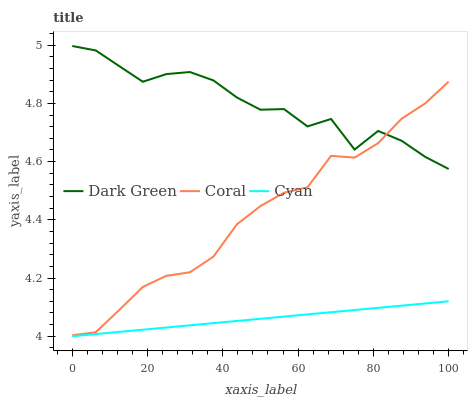Does Cyan have the minimum area under the curve?
Answer yes or no. Yes. Does Dark Green have the maximum area under the curve?
Answer yes or no. Yes. Does Coral have the minimum area under the curve?
Answer yes or no. No. Does Coral have the maximum area under the curve?
Answer yes or no. No. Is Cyan the smoothest?
Answer yes or no. Yes. Is Dark Green the roughest?
Answer yes or no. Yes. Is Coral the smoothest?
Answer yes or no. No. Is Coral the roughest?
Answer yes or no. No. Does Cyan have the lowest value?
Answer yes or no. Yes. Does Coral have the lowest value?
Answer yes or no. No. Does Dark Green have the highest value?
Answer yes or no. Yes. Does Coral have the highest value?
Answer yes or no. No. Is Cyan less than Dark Green?
Answer yes or no. Yes. Is Dark Green greater than Cyan?
Answer yes or no. Yes. Does Dark Green intersect Coral?
Answer yes or no. Yes. Is Dark Green less than Coral?
Answer yes or no. No. Is Dark Green greater than Coral?
Answer yes or no. No. Does Cyan intersect Dark Green?
Answer yes or no. No. 